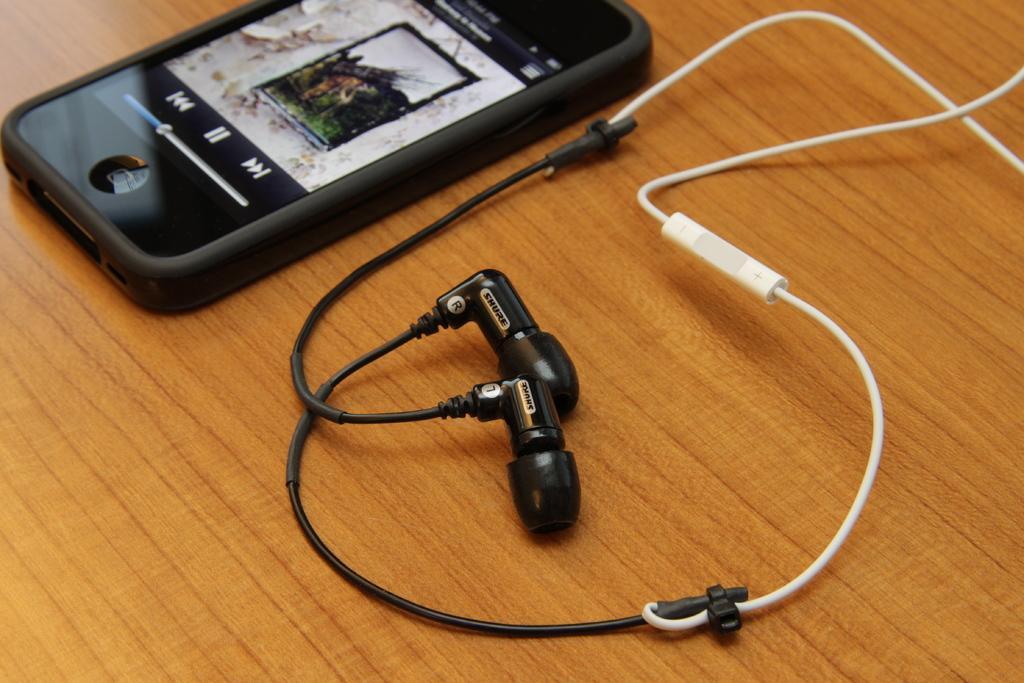Could you give a brief overview of what you see in this image? In the picture I can see a mobile phone on which we can see something is displayed and earphones are placed on the wooden surface. 